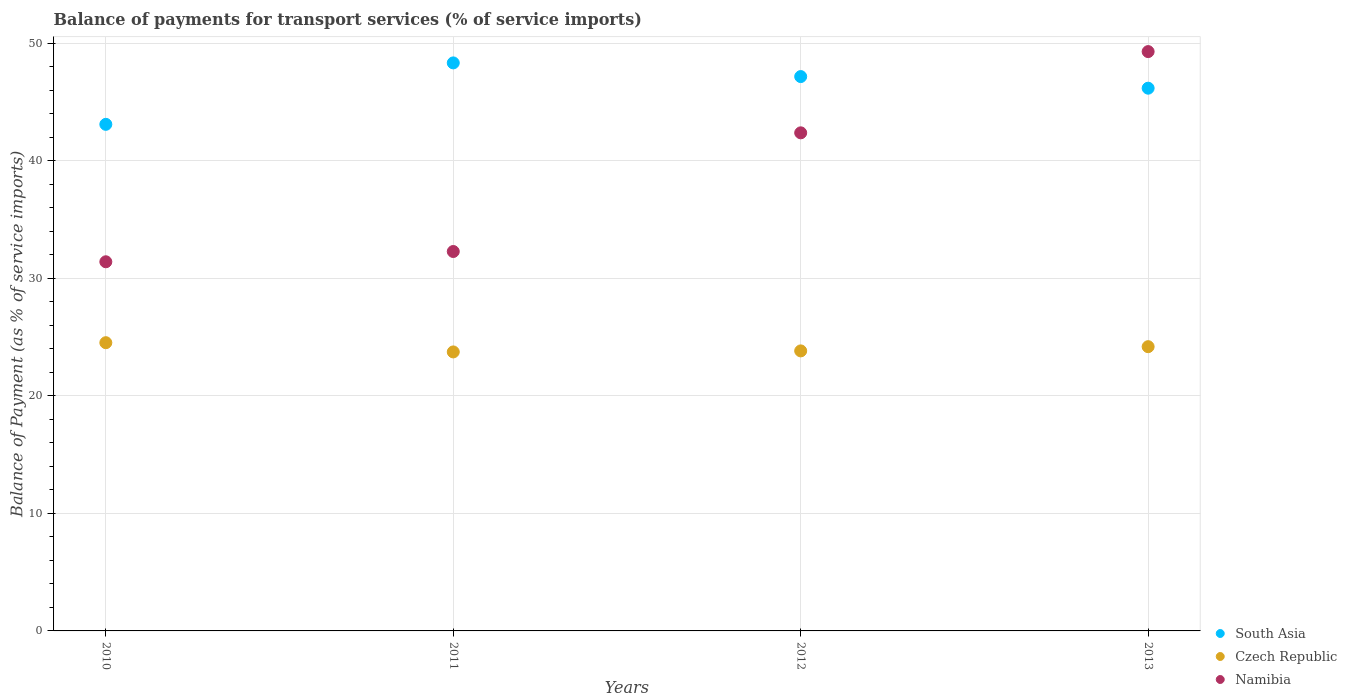What is the balance of payments for transport services in South Asia in 2012?
Provide a succinct answer. 47.17. Across all years, what is the maximum balance of payments for transport services in Czech Republic?
Ensure brevity in your answer.  24.53. Across all years, what is the minimum balance of payments for transport services in Namibia?
Your answer should be compact. 31.41. In which year was the balance of payments for transport services in South Asia maximum?
Your answer should be very brief. 2011. What is the total balance of payments for transport services in Czech Republic in the graph?
Give a very brief answer. 96.29. What is the difference between the balance of payments for transport services in Czech Republic in 2010 and that in 2012?
Provide a short and direct response. 0.7. What is the difference between the balance of payments for transport services in South Asia in 2013 and the balance of payments for transport services in Namibia in 2010?
Give a very brief answer. 14.77. What is the average balance of payments for transport services in South Asia per year?
Offer a terse response. 46.2. In the year 2013, what is the difference between the balance of payments for transport services in Namibia and balance of payments for transport services in South Asia?
Ensure brevity in your answer.  3.11. In how many years, is the balance of payments for transport services in Czech Republic greater than 16 %?
Your answer should be very brief. 4. What is the ratio of the balance of payments for transport services in South Asia in 2010 to that in 2011?
Make the answer very short. 0.89. Is the difference between the balance of payments for transport services in Namibia in 2010 and 2011 greater than the difference between the balance of payments for transport services in South Asia in 2010 and 2011?
Give a very brief answer. Yes. What is the difference between the highest and the second highest balance of payments for transport services in South Asia?
Keep it short and to the point. 1.16. What is the difference between the highest and the lowest balance of payments for transport services in Namibia?
Provide a succinct answer. 17.89. Is the sum of the balance of payments for transport services in South Asia in 2010 and 2011 greater than the maximum balance of payments for transport services in Czech Republic across all years?
Make the answer very short. Yes. Is it the case that in every year, the sum of the balance of payments for transport services in Czech Republic and balance of payments for transport services in Namibia  is greater than the balance of payments for transport services in South Asia?
Ensure brevity in your answer.  Yes. Is the balance of payments for transport services in South Asia strictly greater than the balance of payments for transport services in Namibia over the years?
Keep it short and to the point. No. How many years are there in the graph?
Offer a very short reply. 4. What is the difference between two consecutive major ticks on the Y-axis?
Your answer should be compact. 10. Are the values on the major ticks of Y-axis written in scientific E-notation?
Keep it short and to the point. No. Does the graph contain any zero values?
Give a very brief answer. No. Where does the legend appear in the graph?
Offer a terse response. Bottom right. What is the title of the graph?
Offer a very short reply. Balance of payments for transport services (% of service imports). What is the label or title of the X-axis?
Offer a very short reply. Years. What is the label or title of the Y-axis?
Your response must be concise. Balance of Payment (as % of service imports). What is the Balance of Payment (as % of service imports) in South Asia in 2010?
Give a very brief answer. 43.11. What is the Balance of Payment (as % of service imports) in Czech Republic in 2010?
Your answer should be compact. 24.53. What is the Balance of Payment (as % of service imports) in Namibia in 2010?
Your response must be concise. 31.41. What is the Balance of Payment (as % of service imports) of South Asia in 2011?
Give a very brief answer. 48.34. What is the Balance of Payment (as % of service imports) in Czech Republic in 2011?
Give a very brief answer. 23.74. What is the Balance of Payment (as % of service imports) of Namibia in 2011?
Your answer should be very brief. 32.29. What is the Balance of Payment (as % of service imports) of South Asia in 2012?
Make the answer very short. 47.17. What is the Balance of Payment (as % of service imports) in Czech Republic in 2012?
Keep it short and to the point. 23.83. What is the Balance of Payment (as % of service imports) in Namibia in 2012?
Offer a terse response. 42.39. What is the Balance of Payment (as % of service imports) in South Asia in 2013?
Your answer should be compact. 46.18. What is the Balance of Payment (as % of service imports) in Czech Republic in 2013?
Provide a succinct answer. 24.19. What is the Balance of Payment (as % of service imports) in Namibia in 2013?
Your answer should be compact. 49.3. Across all years, what is the maximum Balance of Payment (as % of service imports) of South Asia?
Your answer should be compact. 48.34. Across all years, what is the maximum Balance of Payment (as % of service imports) in Czech Republic?
Provide a short and direct response. 24.53. Across all years, what is the maximum Balance of Payment (as % of service imports) in Namibia?
Offer a very short reply. 49.3. Across all years, what is the minimum Balance of Payment (as % of service imports) of South Asia?
Offer a terse response. 43.11. Across all years, what is the minimum Balance of Payment (as % of service imports) in Czech Republic?
Provide a short and direct response. 23.74. Across all years, what is the minimum Balance of Payment (as % of service imports) in Namibia?
Offer a terse response. 31.41. What is the total Balance of Payment (as % of service imports) in South Asia in the graph?
Your answer should be very brief. 184.8. What is the total Balance of Payment (as % of service imports) of Czech Republic in the graph?
Give a very brief answer. 96.29. What is the total Balance of Payment (as % of service imports) in Namibia in the graph?
Your response must be concise. 155.39. What is the difference between the Balance of Payment (as % of service imports) in South Asia in 2010 and that in 2011?
Give a very brief answer. -5.23. What is the difference between the Balance of Payment (as % of service imports) in Czech Republic in 2010 and that in 2011?
Ensure brevity in your answer.  0.79. What is the difference between the Balance of Payment (as % of service imports) of Namibia in 2010 and that in 2011?
Your response must be concise. -0.87. What is the difference between the Balance of Payment (as % of service imports) in South Asia in 2010 and that in 2012?
Ensure brevity in your answer.  -4.06. What is the difference between the Balance of Payment (as % of service imports) in Czech Republic in 2010 and that in 2012?
Ensure brevity in your answer.  0.7. What is the difference between the Balance of Payment (as % of service imports) in Namibia in 2010 and that in 2012?
Offer a very short reply. -10.97. What is the difference between the Balance of Payment (as % of service imports) of South Asia in 2010 and that in 2013?
Offer a very short reply. -3.08. What is the difference between the Balance of Payment (as % of service imports) of Czech Republic in 2010 and that in 2013?
Offer a very short reply. 0.34. What is the difference between the Balance of Payment (as % of service imports) in Namibia in 2010 and that in 2013?
Ensure brevity in your answer.  -17.89. What is the difference between the Balance of Payment (as % of service imports) of South Asia in 2011 and that in 2012?
Provide a short and direct response. 1.16. What is the difference between the Balance of Payment (as % of service imports) in Czech Republic in 2011 and that in 2012?
Keep it short and to the point. -0.09. What is the difference between the Balance of Payment (as % of service imports) of Namibia in 2011 and that in 2012?
Ensure brevity in your answer.  -10.1. What is the difference between the Balance of Payment (as % of service imports) in South Asia in 2011 and that in 2013?
Your answer should be very brief. 2.15. What is the difference between the Balance of Payment (as % of service imports) in Czech Republic in 2011 and that in 2013?
Offer a very short reply. -0.45. What is the difference between the Balance of Payment (as % of service imports) of Namibia in 2011 and that in 2013?
Your answer should be compact. -17.01. What is the difference between the Balance of Payment (as % of service imports) of South Asia in 2012 and that in 2013?
Your answer should be very brief. 0.99. What is the difference between the Balance of Payment (as % of service imports) of Czech Republic in 2012 and that in 2013?
Your answer should be very brief. -0.36. What is the difference between the Balance of Payment (as % of service imports) of Namibia in 2012 and that in 2013?
Your answer should be very brief. -6.91. What is the difference between the Balance of Payment (as % of service imports) of South Asia in 2010 and the Balance of Payment (as % of service imports) of Czech Republic in 2011?
Provide a succinct answer. 19.37. What is the difference between the Balance of Payment (as % of service imports) in South Asia in 2010 and the Balance of Payment (as % of service imports) in Namibia in 2011?
Give a very brief answer. 10.82. What is the difference between the Balance of Payment (as % of service imports) of Czech Republic in 2010 and the Balance of Payment (as % of service imports) of Namibia in 2011?
Provide a succinct answer. -7.76. What is the difference between the Balance of Payment (as % of service imports) of South Asia in 2010 and the Balance of Payment (as % of service imports) of Czech Republic in 2012?
Keep it short and to the point. 19.28. What is the difference between the Balance of Payment (as % of service imports) in South Asia in 2010 and the Balance of Payment (as % of service imports) in Namibia in 2012?
Your answer should be compact. 0.72. What is the difference between the Balance of Payment (as % of service imports) of Czech Republic in 2010 and the Balance of Payment (as % of service imports) of Namibia in 2012?
Your answer should be compact. -17.86. What is the difference between the Balance of Payment (as % of service imports) in South Asia in 2010 and the Balance of Payment (as % of service imports) in Czech Republic in 2013?
Offer a very short reply. 18.92. What is the difference between the Balance of Payment (as % of service imports) of South Asia in 2010 and the Balance of Payment (as % of service imports) of Namibia in 2013?
Offer a terse response. -6.19. What is the difference between the Balance of Payment (as % of service imports) of Czech Republic in 2010 and the Balance of Payment (as % of service imports) of Namibia in 2013?
Provide a short and direct response. -24.77. What is the difference between the Balance of Payment (as % of service imports) of South Asia in 2011 and the Balance of Payment (as % of service imports) of Czech Republic in 2012?
Ensure brevity in your answer.  24.51. What is the difference between the Balance of Payment (as % of service imports) in South Asia in 2011 and the Balance of Payment (as % of service imports) in Namibia in 2012?
Provide a succinct answer. 5.95. What is the difference between the Balance of Payment (as % of service imports) in Czech Republic in 2011 and the Balance of Payment (as % of service imports) in Namibia in 2012?
Keep it short and to the point. -18.64. What is the difference between the Balance of Payment (as % of service imports) of South Asia in 2011 and the Balance of Payment (as % of service imports) of Czech Republic in 2013?
Your response must be concise. 24.15. What is the difference between the Balance of Payment (as % of service imports) of South Asia in 2011 and the Balance of Payment (as % of service imports) of Namibia in 2013?
Keep it short and to the point. -0.96. What is the difference between the Balance of Payment (as % of service imports) in Czech Republic in 2011 and the Balance of Payment (as % of service imports) in Namibia in 2013?
Offer a terse response. -25.56. What is the difference between the Balance of Payment (as % of service imports) in South Asia in 2012 and the Balance of Payment (as % of service imports) in Czech Republic in 2013?
Your response must be concise. 22.98. What is the difference between the Balance of Payment (as % of service imports) in South Asia in 2012 and the Balance of Payment (as % of service imports) in Namibia in 2013?
Keep it short and to the point. -2.13. What is the difference between the Balance of Payment (as % of service imports) in Czech Republic in 2012 and the Balance of Payment (as % of service imports) in Namibia in 2013?
Provide a succinct answer. -25.47. What is the average Balance of Payment (as % of service imports) of South Asia per year?
Keep it short and to the point. 46.2. What is the average Balance of Payment (as % of service imports) in Czech Republic per year?
Your response must be concise. 24.07. What is the average Balance of Payment (as % of service imports) of Namibia per year?
Offer a terse response. 38.85. In the year 2010, what is the difference between the Balance of Payment (as % of service imports) of South Asia and Balance of Payment (as % of service imports) of Czech Republic?
Provide a short and direct response. 18.58. In the year 2010, what is the difference between the Balance of Payment (as % of service imports) of South Asia and Balance of Payment (as % of service imports) of Namibia?
Offer a very short reply. 11.7. In the year 2010, what is the difference between the Balance of Payment (as % of service imports) of Czech Republic and Balance of Payment (as % of service imports) of Namibia?
Your answer should be compact. -6.89. In the year 2011, what is the difference between the Balance of Payment (as % of service imports) of South Asia and Balance of Payment (as % of service imports) of Czech Republic?
Provide a short and direct response. 24.59. In the year 2011, what is the difference between the Balance of Payment (as % of service imports) in South Asia and Balance of Payment (as % of service imports) in Namibia?
Keep it short and to the point. 16.05. In the year 2011, what is the difference between the Balance of Payment (as % of service imports) in Czech Republic and Balance of Payment (as % of service imports) in Namibia?
Offer a terse response. -8.55. In the year 2012, what is the difference between the Balance of Payment (as % of service imports) of South Asia and Balance of Payment (as % of service imports) of Czech Republic?
Make the answer very short. 23.34. In the year 2012, what is the difference between the Balance of Payment (as % of service imports) of South Asia and Balance of Payment (as % of service imports) of Namibia?
Keep it short and to the point. 4.79. In the year 2012, what is the difference between the Balance of Payment (as % of service imports) in Czech Republic and Balance of Payment (as % of service imports) in Namibia?
Your response must be concise. -18.56. In the year 2013, what is the difference between the Balance of Payment (as % of service imports) of South Asia and Balance of Payment (as % of service imports) of Czech Republic?
Provide a succinct answer. 22. In the year 2013, what is the difference between the Balance of Payment (as % of service imports) in South Asia and Balance of Payment (as % of service imports) in Namibia?
Your response must be concise. -3.11. In the year 2013, what is the difference between the Balance of Payment (as % of service imports) of Czech Republic and Balance of Payment (as % of service imports) of Namibia?
Keep it short and to the point. -25.11. What is the ratio of the Balance of Payment (as % of service imports) of South Asia in 2010 to that in 2011?
Make the answer very short. 0.89. What is the ratio of the Balance of Payment (as % of service imports) in Czech Republic in 2010 to that in 2011?
Provide a succinct answer. 1.03. What is the ratio of the Balance of Payment (as % of service imports) of Namibia in 2010 to that in 2011?
Your response must be concise. 0.97. What is the ratio of the Balance of Payment (as % of service imports) in South Asia in 2010 to that in 2012?
Give a very brief answer. 0.91. What is the ratio of the Balance of Payment (as % of service imports) in Czech Republic in 2010 to that in 2012?
Your response must be concise. 1.03. What is the ratio of the Balance of Payment (as % of service imports) of Namibia in 2010 to that in 2012?
Your answer should be compact. 0.74. What is the ratio of the Balance of Payment (as % of service imports) of South Asia in 2010 to that in 2013?
Provide a short and direct response. 0.93. What is the ratio of the Balance of Payment (as % of service imports) in Czech Republic in 2010 to that in 2013?
Your answer should be compact. 1.01. What is the ratio of the Balance of Payment (as % of service imports) in Namibia in 2010 to that in 2013?
Offer a terse response. 0.64. What is the ratio of the Balance of Payment (as % of service imports) of South Asia in 2011 to that in 2012?
Give a very brief answer. 1.02. What is the ratio of the Balance of Payment (as % of service imports) in Czech Republic in 2011 to that in 2012?
Provide a succinct answer. 1. What is the ratio of the Balance of Payment (as % of service imports) in Namibia in 2011 to that in 2012?
Make the answer very short. 0.76. What is the ratio of the Balance of Payment (as % of service imports) in South Asia in 2011 to that in 2013?
Provide a succinct answer. 1.05. What is the ratio of the Balance of Payment (as % of service imports) in Czech Republic in 2011 to that in 2013?
Make the answer very short. 0.98. What is the ratio of the Balance of Payment (as % of service imports) of Namibia in 2011 to that in 2013?
Give a very brief answer. 0.65. What is the ratio of the Balance of Payment (as % of service imports) in South Asia in 2012 to that in 2013?
Offer a terse response. 1.02. What is the ratio of the Balance of Payment (as % of service imports) of Czech Republic in 2012 to that in 2013?
Your response must be concise. 0.99. What is the ratio of the Balance of Payment (as % of service imports) in Namibia in 2012 to that in 2013?
Your answer should be compact. 0.86. What is the difference between the highest and the second highest Balance of Payment (as % of service imports) of South Asia?
Ensure brevity in your answer.  1.16. What is the difference between the highest and the second highest Balance of Payment (as % of service imports) of Czech Republic?
Keep it short and to the point. 0.34. What is the difference between the highest and the second highest Balance of Payment (as % of service imports) of Namibia?
Your answer should be very brief. 6.91. What is the difference between the highest and the lowest Balance of Payment (as % of service imports) of South Asia?
Offer a very short reply. 5.23. What is the difference between the highest and the lowest Balance of Payment (as % of service imports) in Czech Republic?
Keep it short and to the point. 0.79. What is the difference between the highest and the lowest Balance of Payment (as % of service imports) of Namibia?
Make the answer very short. 17.89. 